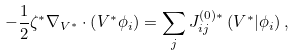Convert formula to latex. <formula><loc_0><loc_0><loc_500><loc_500>- \frac { 1 } { 2 } \zeta ^ { \ast } \nabla _ { V ^ { * } } \cdot \left ( V ^ { \ast } \phi _ { i } \right ) = \sum _ { j } J _ { i j } ^ { ( 0 ) \ast } \left ( V ^ { \ast } | \phi _ { i } \right ) ,</formula> 